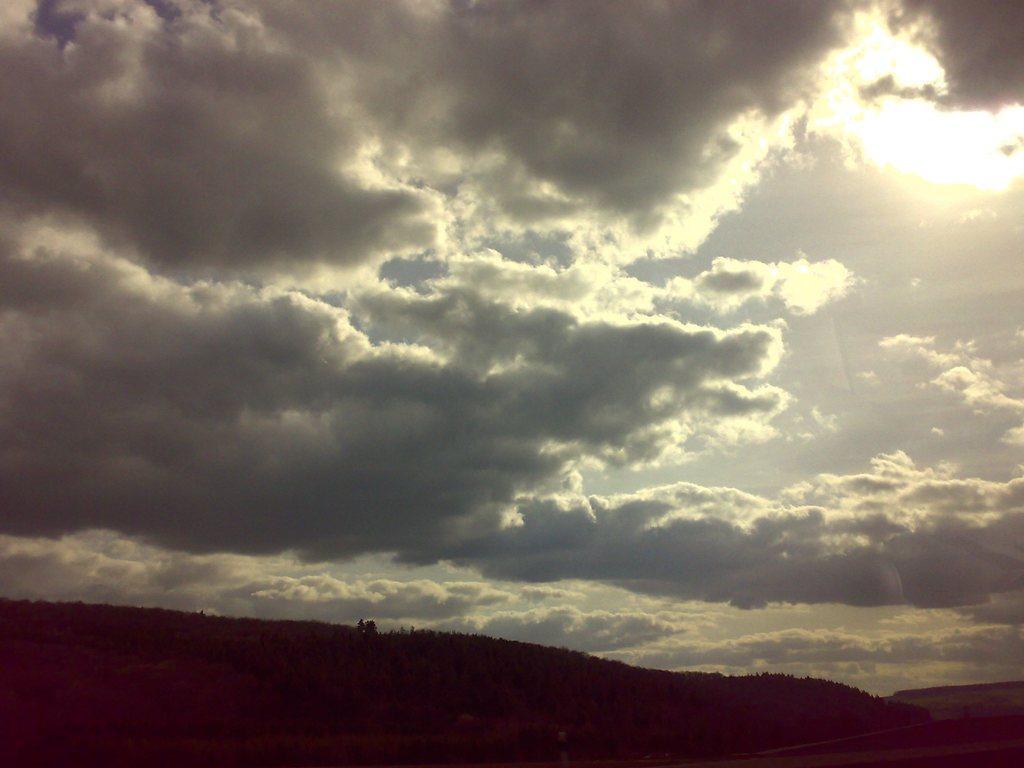How would you summarize this image in a sentence or two? In this image in the center there are trees and the sky is cloudy. 